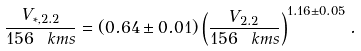<formula> <loc_0><loc_0><loc_500><loc_500>\frac { V _ { \ast , 2 . 2 } } { 1 5 6 \ k m s } = ( 0 . 6 4 \pm 0 . 0 1 ) \left ( \frac { V _ { 2 . 2 } } { 1 5 6 \ k m s } \right ) ^ { 1 . 1 6 \pm 0 . 0 5 } .</formula> 